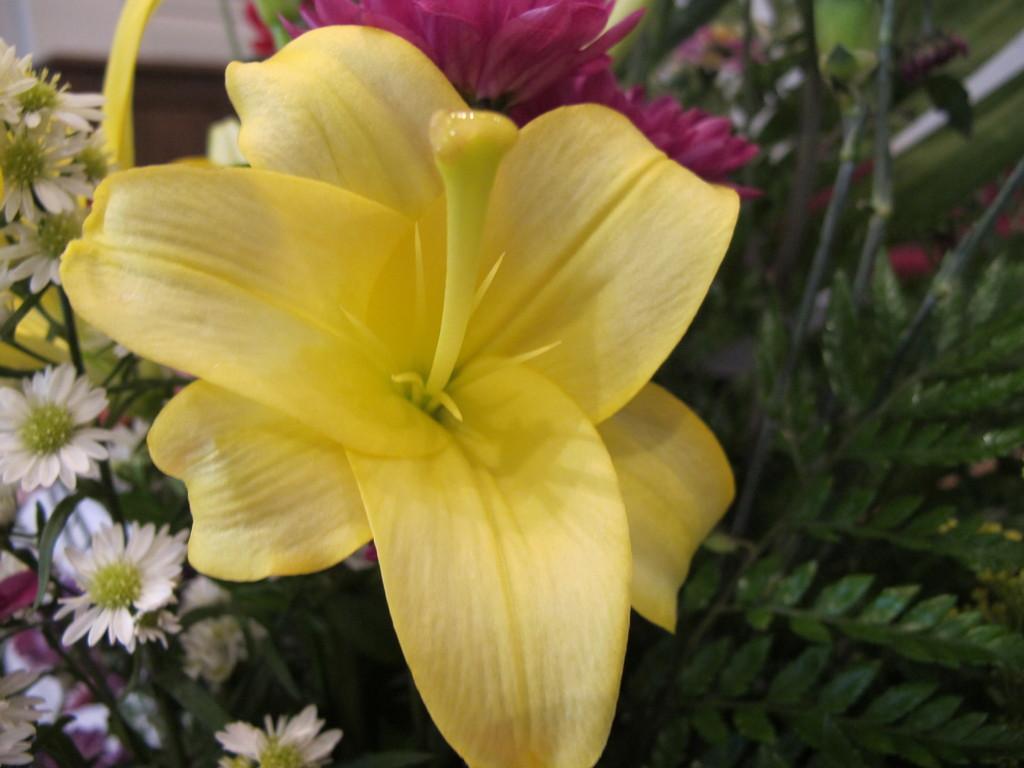Can you describe this image briefly? In this picture there are flowers on the plant and the flowers are in white, yellow and in pink colors. At the back it looks like a wall. 